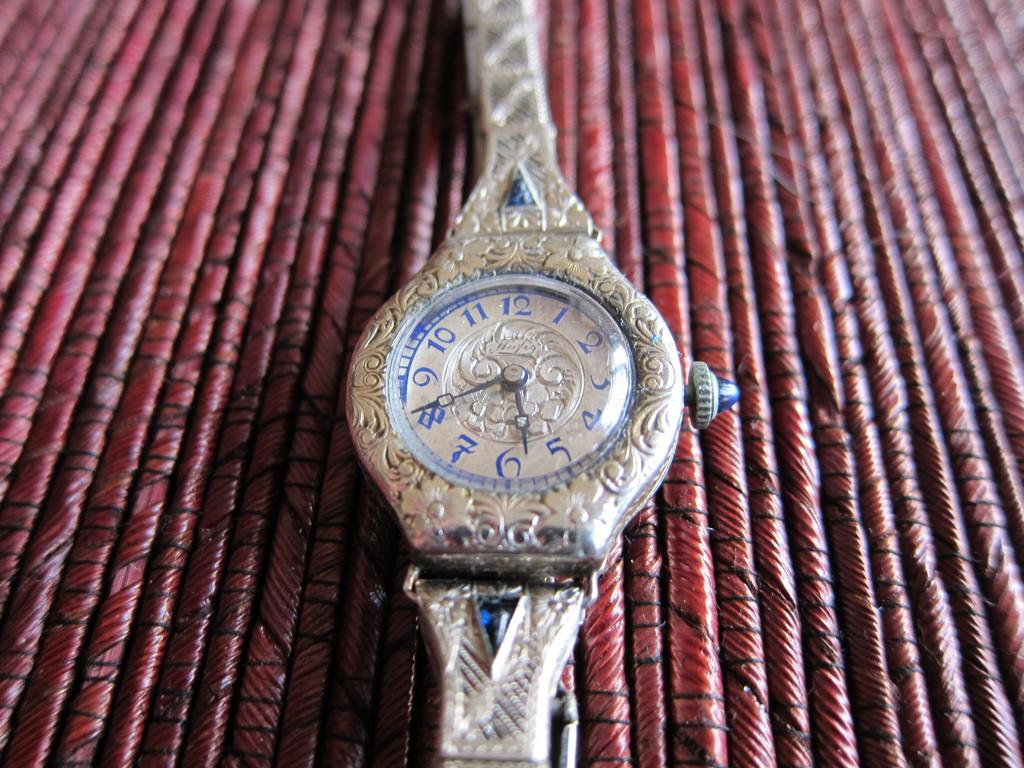Provide a one-sentence caption for the provided image. An intricately carved silver ladie's watch by Herfig. 